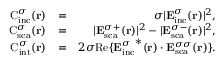<formula> <loc_0><loc_0><loc_500><loc_500>\begin{array} { r l r } { C _ { i n c } ^ { \sigma } ( { r } ) } & { = } & { \sigma | { E } _ { i n c } ^ { \sigma } ( { r } ) | ^ { 2 } , } \\ { C _ { s c a } ^ { \sigma } ( { r } ) } & { = } & { | { E } _ { s c a } ^ { \sigma + } ( { r } ) | ^ { 2 } - | { E } _ { s c a } ^ { \sigma - } ( { r } ) | ^ { 2 } , } \\ { C _ { i n t } ^ { \sigma } ( { r } ) } & { = } & { 2 \sigma R e \{ { { E } _ { i n c } ^ { \sigma } } ^ { * } ( { r } ) \cdot { { E } _ { s c a } ^ { \sigma \sigma } } ( { r } ) \} . } \end{array}</formula> 